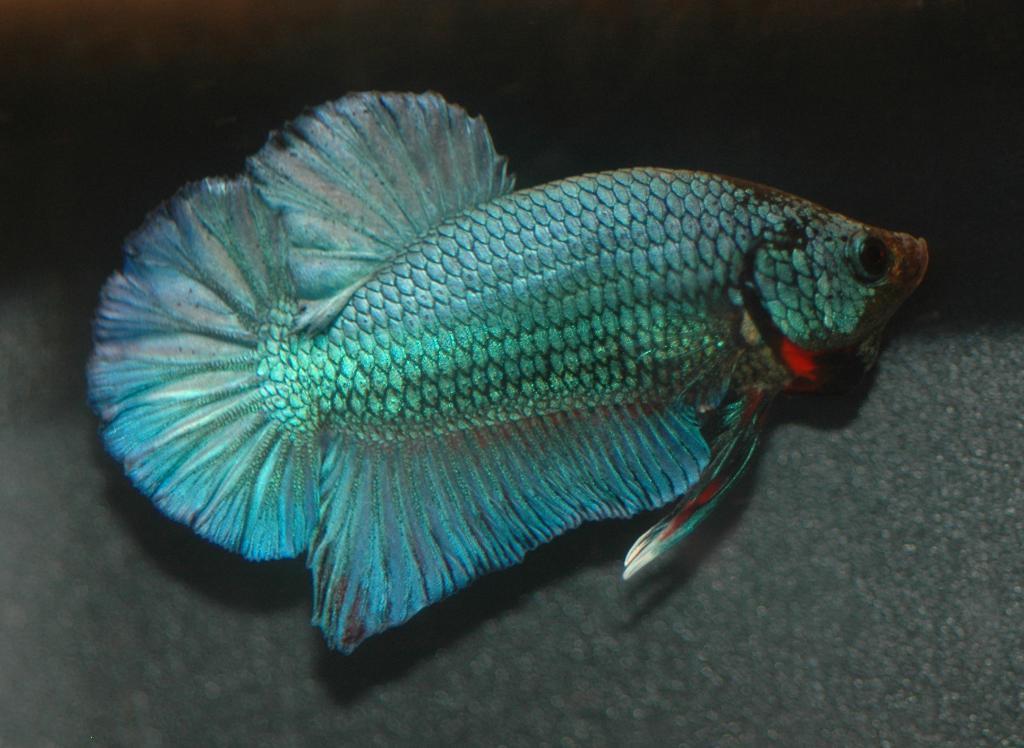Describe this image in one or two sentences. In this picture, we see a silver color fish. At the bottom, it is grey in color. In the background, it is black in color. This picture might be clicked in the aquarium. 